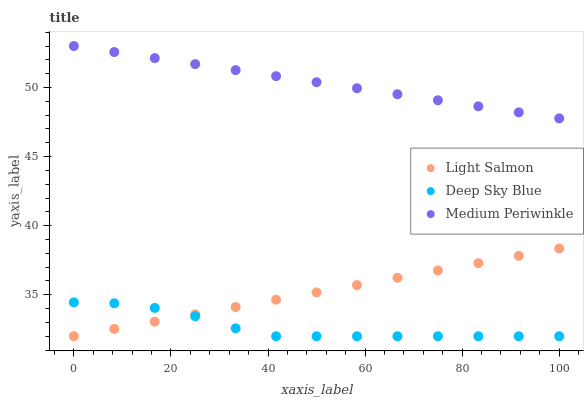Does Deep Sky Blue have the minimum area under the curve?
Answer yes or no. Yes. Does Medium Periwinkle have the maximum area under the curve?
Answer yes or no. Yes. Does Medium Periwinkle have the minimum area under the curve?
Answer yes or no. No. Does Deep Sky Blue have the maximum area under the curve?
Answer yes or no. No. Is Medium Periwinkle the smoothest?
Answer yes or no. Yes. Is Deep Sky Blue the roughest?
Answer yes or no. Yes. Is Deep Sky Blue the smoothest?
Answer yes or no. No. Is Medium Periwinkle the roughest?
Answer yes or no. No. Does Light Salmon have the lowest value?
Answer yes or no. Yes. Does Medium Periwinkle have the lowest value?
Answer yes or no. No. Does Medium Periwinkle have the highest value?
Answer yes or no. Yes. Does Deep Sky Blue have the highest value?
Answer yes or no. No. Is Light Salmon less than Medium Periwinkle?
Answer yes or no. Yes. Is Medium Periwinkle greater than Deep Sky Blue?
Answer yes or no. Yes. Does Light Salmon intersect Deep Sky Blue?
Answer yes or no. Yes. Is Light Salmon less than Deep Sky Blue?
Answer yes or no. No. Is Light Salmon greater than Deep Sky Blue?
Answer yes or no. No. Does Light Salmon intersect Medium Periwinkle?
Answer yes or no. No. 